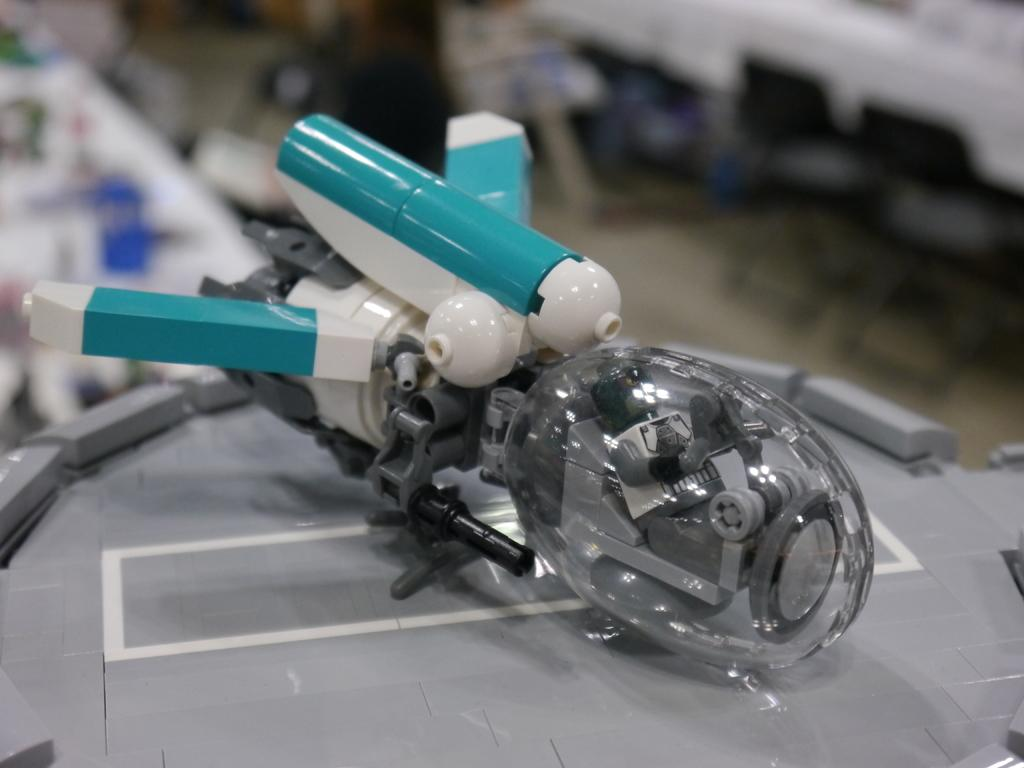How many marbles are being held by the spiders in the image? There are no spiders or marbles present in the image. 